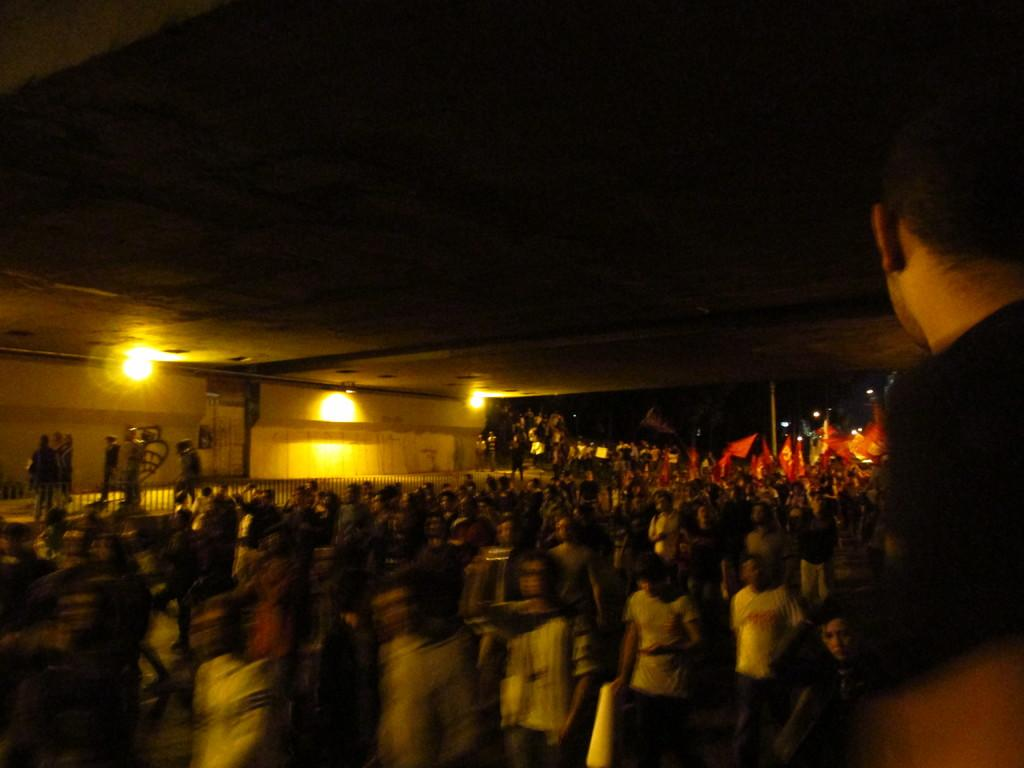How many people are in the image? There is a group of people in the image. What can be seen in the image besides the people? There are lights, a flag, a pole, and some objects in the image. What is the color of the background in the image? The background of the image is dark. Can you see the grandfather wearing a crown in the image? There is no grandfather or crown present in the image. Is there a turkey visible in the image? There is no turkey present in the image. 